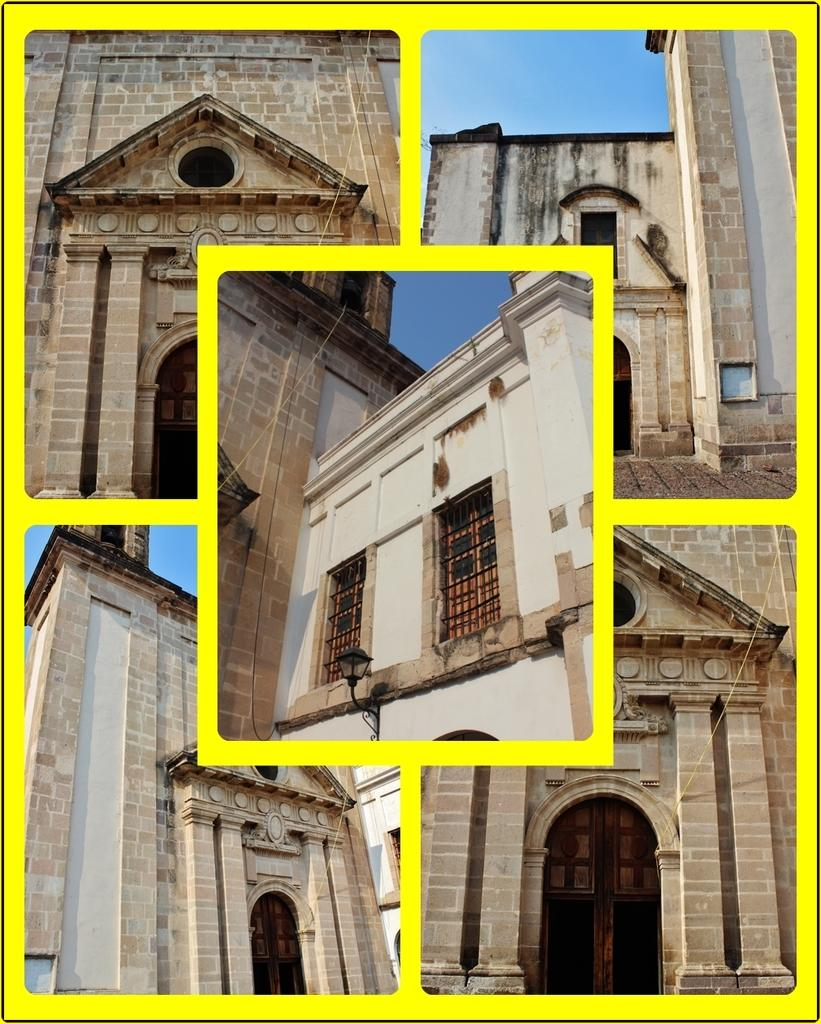What type of structures can be seen in the image? There are buildings in the image. What feature is present on the buildings in the image? There are windows in the image. What is visible at the top of the image? The sky is visible at the top of the image. Can you tell me how many tramps are sitting on the roof in the image? There are no tramps or roofs present in the image; it features buildings with windows and a visible sky. 